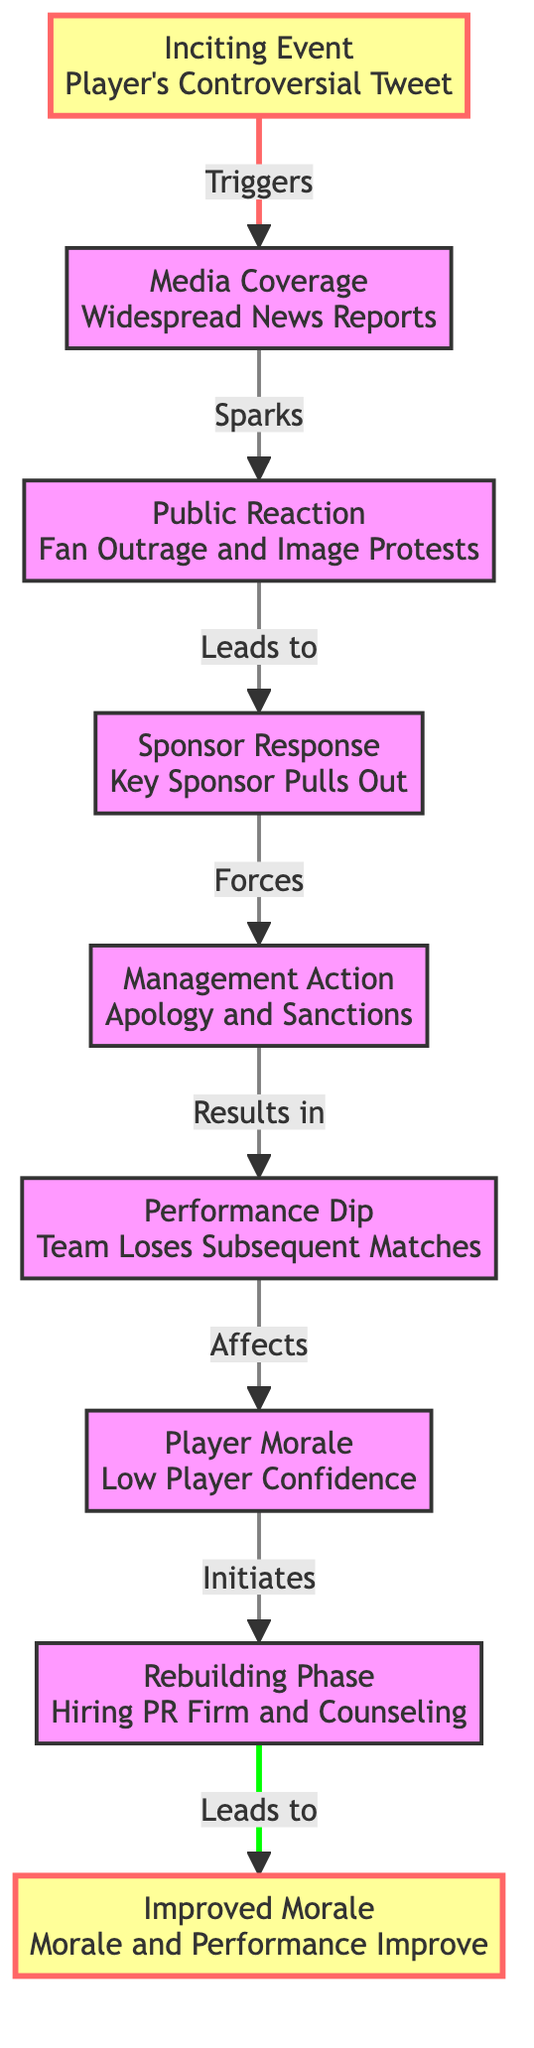What is the inciting event that starts the chain reaction? The first node in the diagram is "Player's Controversial Tweet," which represents the inciting event. Therefore, this is the event that initiates the subsequent events in the chain.
Answer: Player's Controversial Tweet What does the media coverage lead to? Following the "Media Coverage" node labeled "Widespread News Reports," the next node indicates that it sparks "Public Reaction," which captures the resultant effect of the media coverage.
Answer: Public Reaction How many key nodes are there in total? The diagram has a total of nine nodes: each node represents a significant event or response in the flow of negative press events and their consequences, starting from the inciting event to the improved morale.
Answer: Nine What effect does the sponsor's response have? According to the flow of the diagram, the "Sponsor Response" node (Key Sponsor Pulls Out) leads directly to "Management Action" (Apology and Sanctions), indicating the direct consequence of the sponsor's action.
Answer: Management Action What is the final outcome of the timeline? The last node in the diagram is "Improved Morale," which signifies the endpoint of the process after all the challenges and interventions have been accounted for. This reflects the ultimate recovery outcome in the chain.
Answer: Improved Morale What relationship is observed between performance dip and player morale? The flow from "Performance Dip" indicates that this node leads directly to "Player Morale," showing a cause and effect where the dip in performance has a negative impact on player morale.
Answer: Negative impact How does the management action influence team performance? The diagram shows that the "Management Action" (consisting of Apology and Sanctions) results in a "Performance Dip," indicating that these actions have a detrimental effect on the team's performance.
Answer: Detrimental effect Which event comes last in the sequence? The last step in the diagram is "Improved Morale," which concludes the sequence of events listed in the flowchart, showing the final reaction to the earlier events.
Answer: Improved Morale 